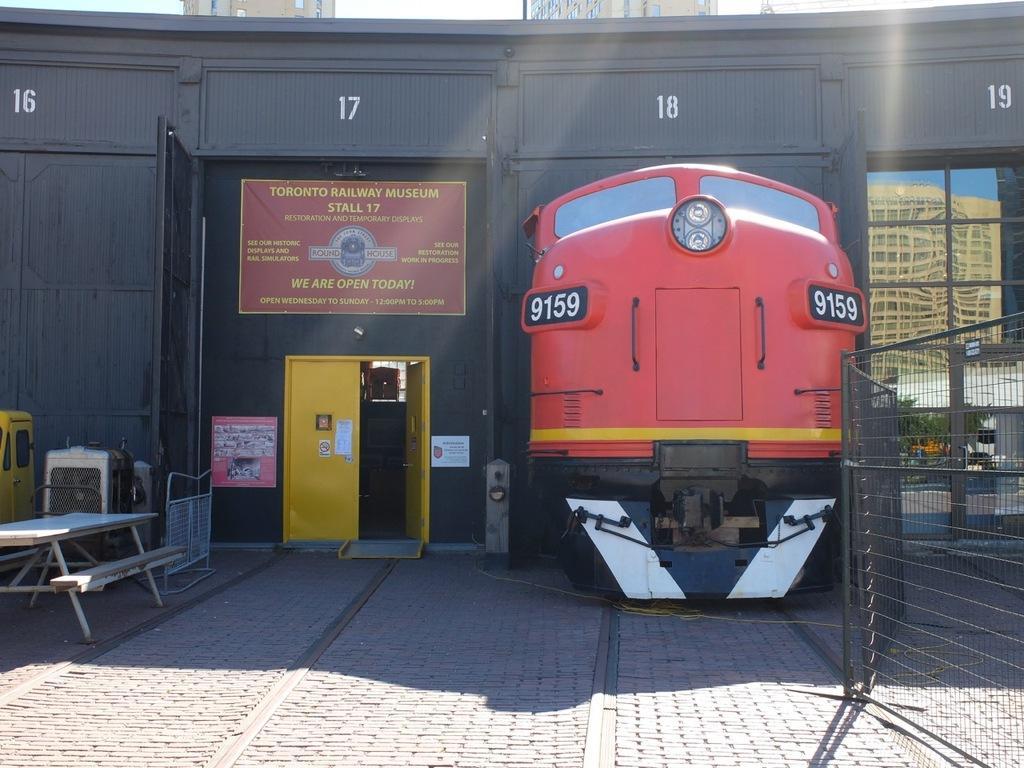How would you summarize this image in a sentence or two? In this image we can see one railway museum, one train on the railway track, one glass window, one yellow door, some numbers on the museum wall, some objects on the surface, backside of the museum there are some buildings, one gate, one fence, some posters with text, some papers attached to the yellow door, one bench with table and at the top there is the sky. 